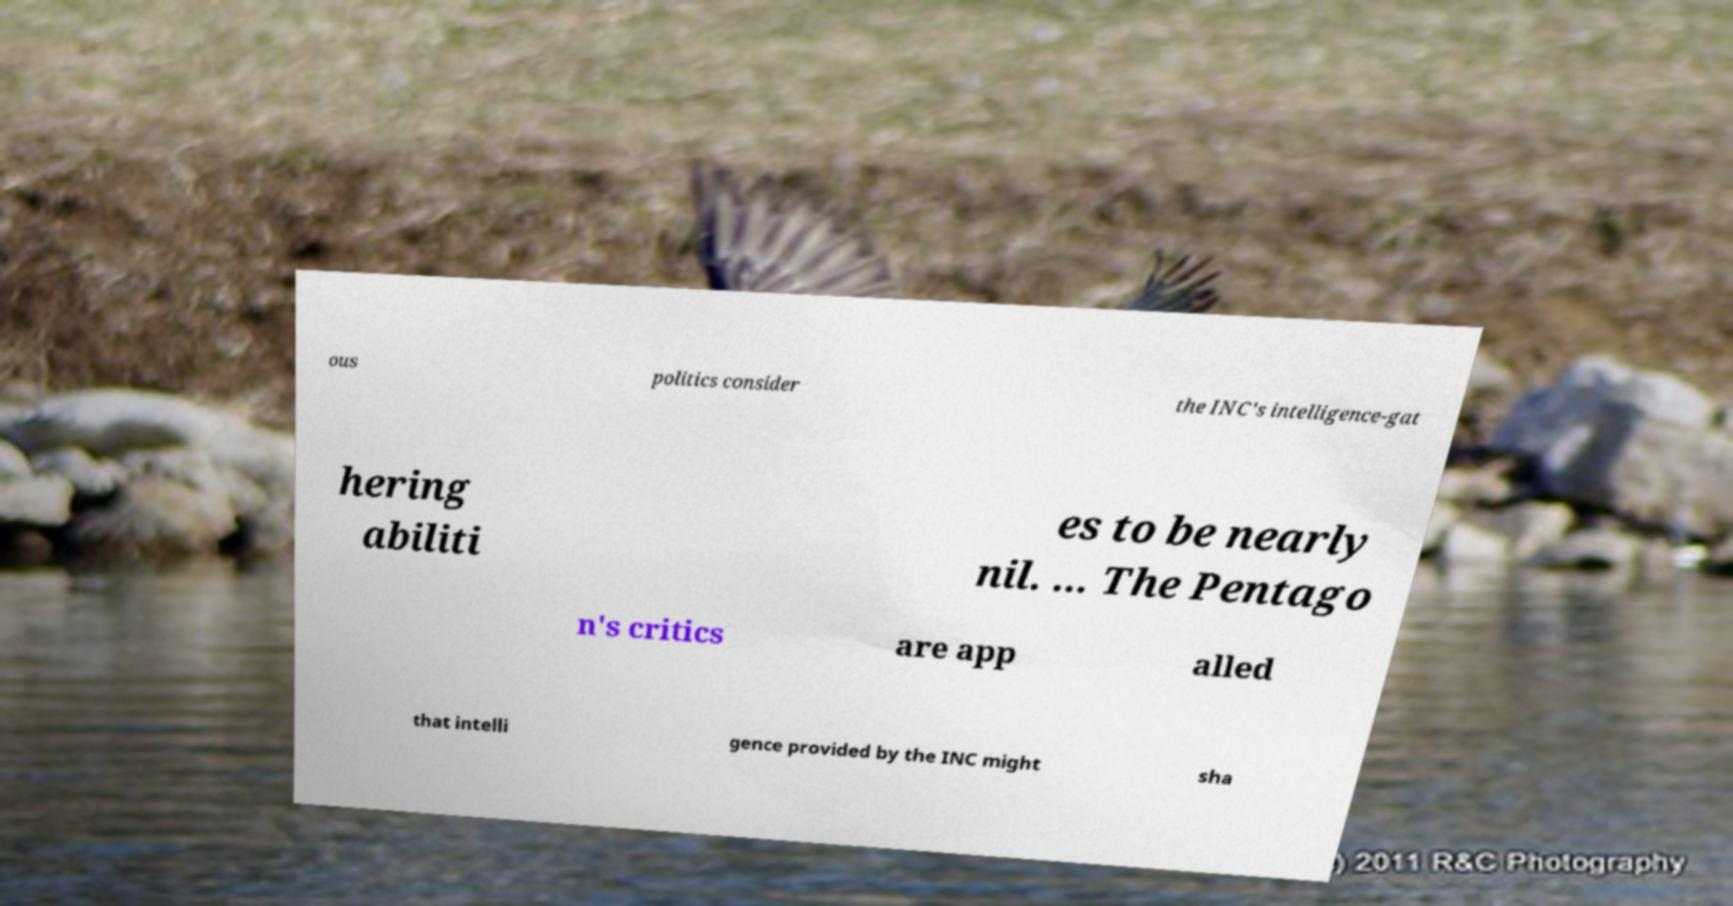For documentation purposes, I need the text within this image transcribed. Could you provide that? ous politics consider the INC's intelligence-gat hering abiliti es to be nearly nil. ... The Pentago n's critics are app alled that intelli gence provided by the INC might sha 